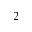<formula> <loc_0><loc_0><loc_500><loc_500>_ { 2 }</formula> 